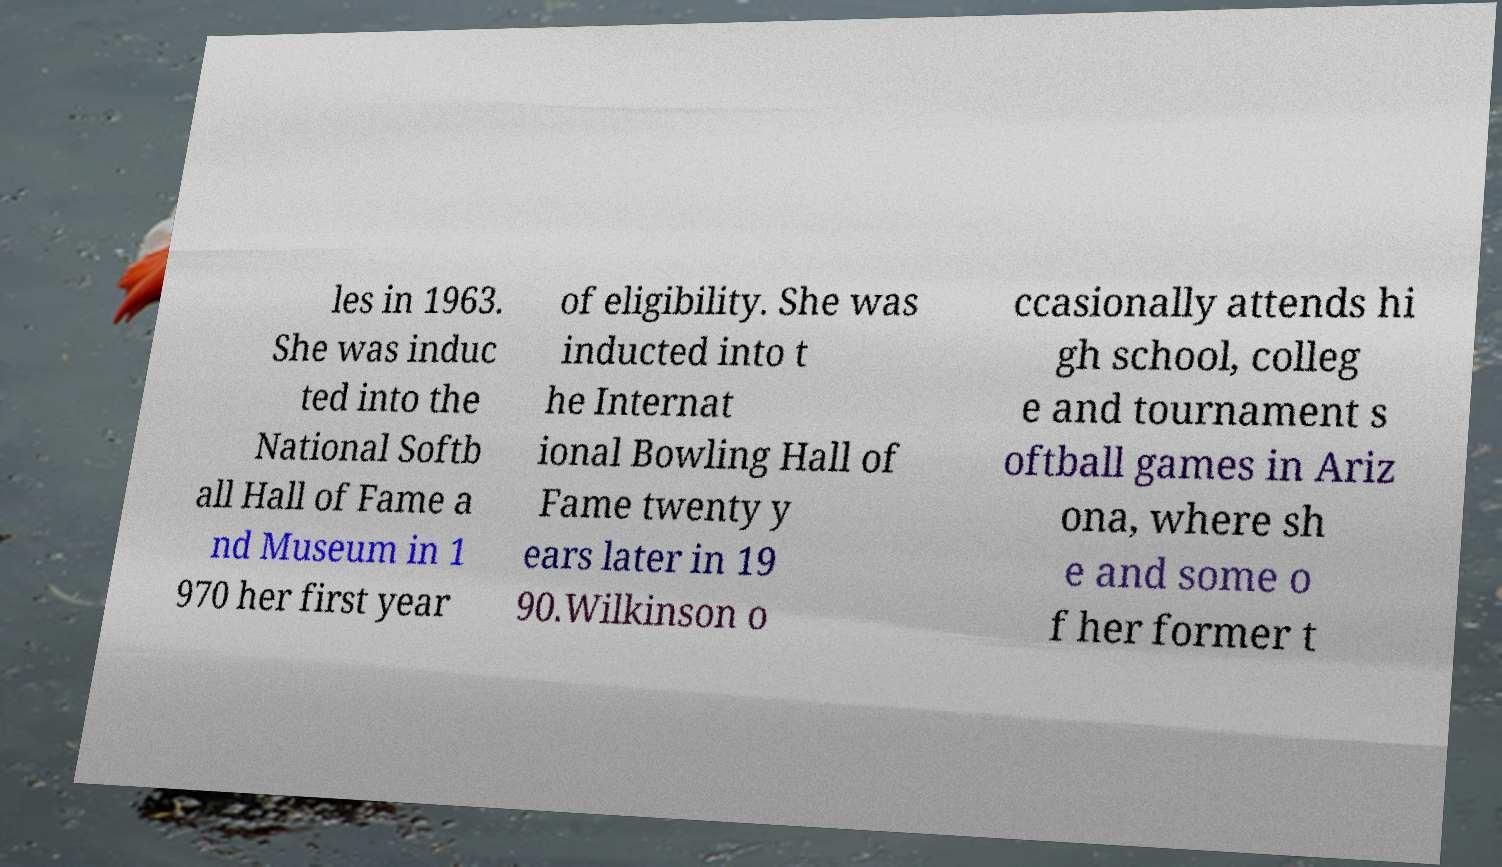Can you accurately transcribe the text from the provided image for me? les in 1963. She was induc ted into the National Softb all Hall of Fame a nd Museum in 1 970 her first year of eligibility. She was inducted into t he Internat ional Bowling Hall of Fame twenty y ears later in 19 90.Wilkinson o ccasionally attends hi gh school, colleg e and tournament s oftball games in Ariz ona, where sh e and some o f her former t 